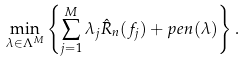<formula> <loc_0><loc_0><loc_500><loc_500>\min _ { \lambda \in \Lambda ^ { M } } \left \{ \sum _ { j = 1 } ^ { M } \lambda _ { j } \hat { R } _ { n } ( f _ { j } ) + p e n ( \lambda ) \right \} .</formula> 